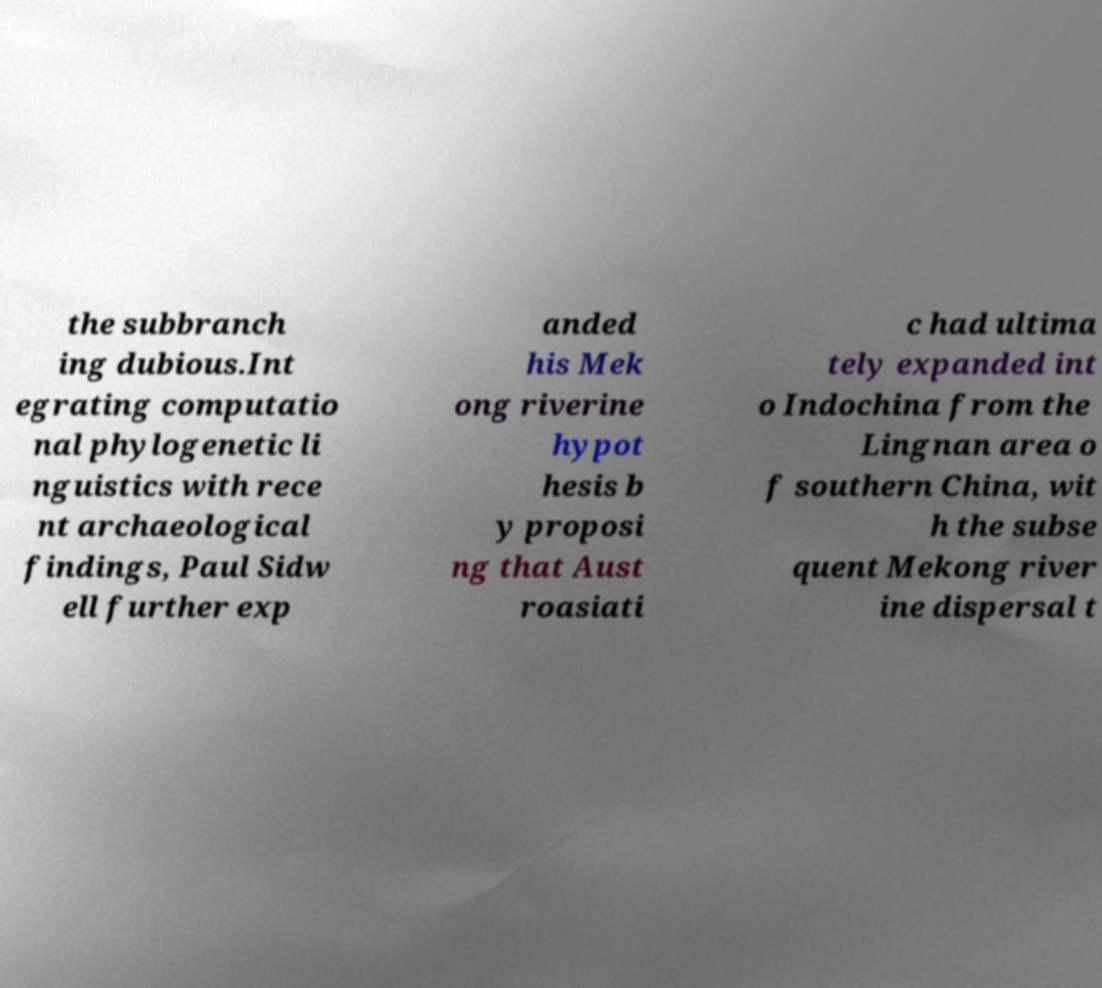I need the written content from this picture converted into text. Can you do that? the subbranch ing dubious.Int egrating computatio nal phylogenetic li nguistics with rece nt archaeological findings, Paul Sidw ell further exp anded his Mek ong riverine hypot hesis b y proposi ng that Aust roasiati c had ultima tely expanded int o Indochina from the Lingnan area o f southern China, wit h the subse quent Mekong river ine dispersal t 